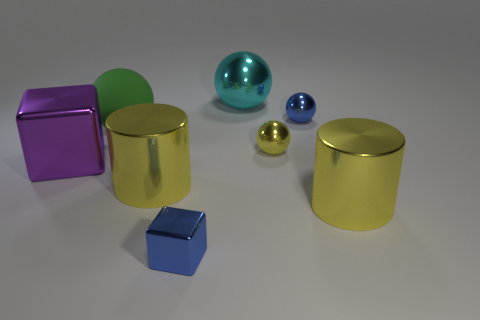Subtract all yellow shiny spheres. How many spheres are left? 3 Add 1 cyan spheres. How many objects exist? 9 Subtract 2 spheres. How many spheres are left? 2 Subtract all green balls. How many balls are left? 3 Subtract all red balls. Subtract all brown blocks. How many balls are left? 4 Add 6 yellow shiny things. How many yellow shiny things are left? 9 Add 7 large red blocks. How many large red blocks exist? 7 Subtract 1 green balls. How many objects are left? 7 Subtract all cylinders. How many objects are left? 6 Subtract all big cyan metal objects. Subtract all rubber things. How many objects are left? 6 